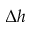<formula> <loc_0><loc_0><loc_500><loc_500>\Delta h</formula> 